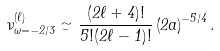Convert formula to latex. <formula><loc_0><loc_0><loc_500><loc_500>\nu _ { \omega = - 2 / 3 } ^ { ( \ell ) } \simeq \frac { ( 2 \ell + 4 ) ! } { 5 ! ( 2 \ell - 1 ) ! } \left ( 2 a \right ) ^ { - 5 / 4 } .</formula> 